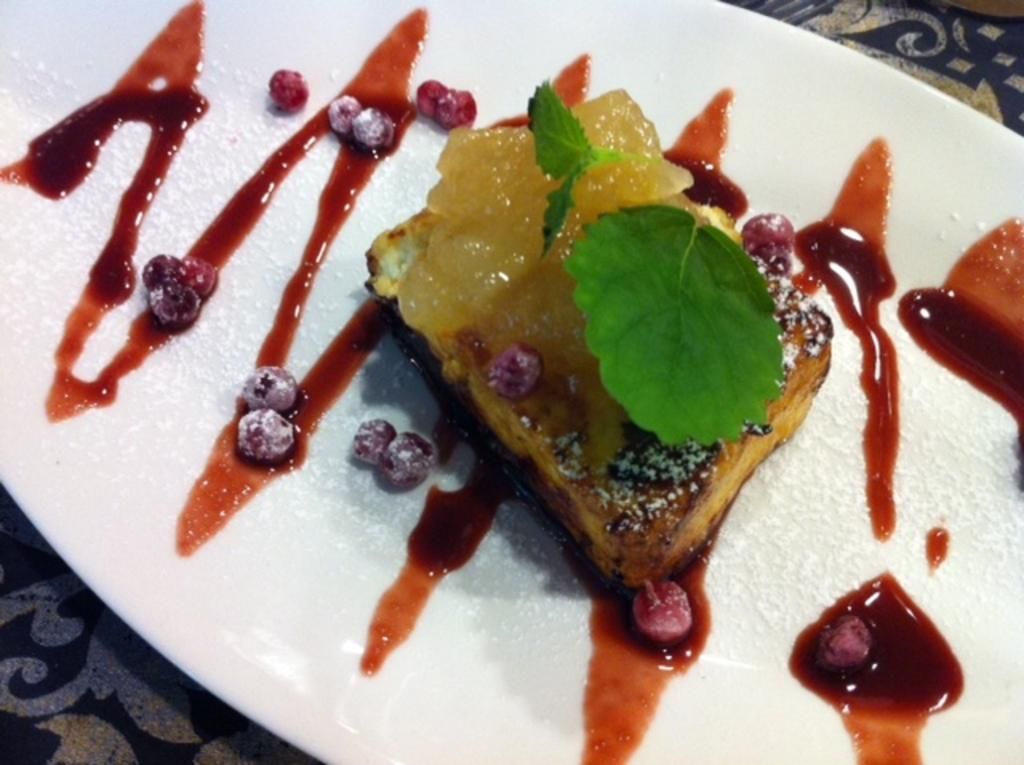What is the main subject of the image? There is a food item in the image. How is the food item being presented or contained? The food item is in a tray. Where is the tray with the food item located? The tray is on a table. How does the mailbox contribute to the digestion of the food item in the image? There is no mailbox present in the image, and therefore it does not contribute to the digestion of the food item. 